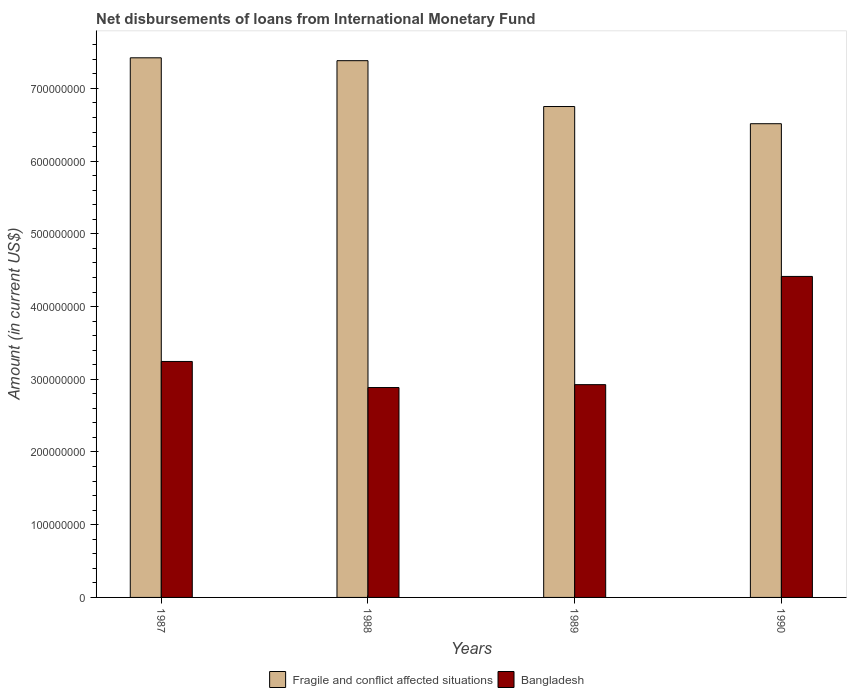Are the number of bars on each tick of the X-axis equal?
Offer a terse response. Yes. In how many cases, is the number of bars for a given year not equal to the number of legend labels?
Provide a succinct answer. 0. What is the amount of loans disbursed in Bangladesh in 1990?
Provide a short and direct response. 4.41e+08. Across all years, what is the maximum amount of loans disbursed in Fragile and conflict affected situations?
Your answer should be compact. 7.42e+08. Across all years, what is the minimum amount of loans disbursed in Bangladesh?
Provide a succinct answer. 2.89e+08. In which year was the amount of loans disbursed in Fragile and conflict affected situations maximum?
Offer a very short reply. 1987. In which year was the amount of loans disbursed in Bangladesh minimum?
Ensure brevity in your answer.  1988. What is the total amount of loans disbursed in Bangladesh in the graph?
Make the answer very short. 1.35e+09. What is the difference between the amount of loans disbursed in Bangladesh in 1987 and that in 1988?
Make the answer very short. 3.59e+07. What is the difference between the amount of loans disbursed in Bangladesh in 1987 and the amount of loans disbursed in Fragile and conflict affected situations in 1990?
Your answer should be very brief. -3.27e+08. What is the average amount of loans disbursed in Fragile and conflict affected situations per year?
Make the answer very short. 7.02e+08. In the year 1990, what is the difference between the amount of loans disbursed in Fragile and conflict affected situations and amount of loans disbursed in Bangladesh?
Offer a terse response. 2.10e+08. What is the ratio of the amount of loans disbursed in Bangladesh in 1987 to that in 1989?
Offer a very short reply. 1.11. Is the amount of loans disbursed in Fragile and conflict affected situations in 1987 less than that in 1988?
Your response must be concise. No. Is the difference between the amount of loans disbursed in Fragile and conflict affected situations in 1987 and 1989 greater than the difference between the amount of loans disbursed in Bangladesh in 1987 and 1989?
Offer a very short reply. Yes. What is the difference between the highest and the second highest amount of loans disbursed in Bangladesh?
Provide a succinct answer. 1.17e+08. What is the difference between the highest and the lowest amount of loans disbursed in Fragile and conflict affected situations?
Your response must be concise. 9.06e+07. Is the sum of the amount of loans disbursed in Fragile and conflict affected situations in 1988 and 1989 greater than the maximum amount of loans disbursed in Bangladesh across all years?
Your response must be concise. Yes. What does the 1st bar from the right in 1988 represents?
Ensure brevity in your answer.  Bangladesh. What is the difference between two consecutive major ticks on the Y-axis?
Make the answer very short. 1.00e+08. Does the graph contain any zero values?
Your response must be concise. No. Does the graph contain grids?
Make the answer very short. No. What is the title of the graph?
Provide a succinct answer. Net disbursements of loans from International Monetary Fund. Does "Heavily indebted poor countries" appear as one of the legend labels in the graph?
Your answer should be very brief. No. What is the Amount (in current US$) of Fragile and conflict affected situations in 1987?
Keep it short and to the point. 7.42e+08. What is the Amount (in current US$) of Bangladesh in 1987?
Offer a terse response. 3.24e+08. What is the Amount (in current US$) in Fragile and conflict affected situations in 1988?
Your answer should be compact. 7.38e+08. What is the Amount (in current US$) in Bangladesh in 1988?
Offer a very short reply. 2.89e+08. What is the Amount (in current US$) of Fragile and conflict affected situations in 1989?
Offer a very short reply. 6.75e+08. What is the Amount (in current US$) of Bangladesh in 1989?
Your response must be concise. 2.93e+08. What is the Amount (in current US$) in Fragile and conflict affected situations in 1990?
Your answer should be very brief. 6.51e+08. What is the Amount (in current US$) in Bangladesh in 1990?
Make the answer very short. 4.41e+08. Across all years, what is the maximum Amount (in current US$) of Fragile and conflict affected situations?
Offer a terse response. 7.42e+08. Across all years, what is the maximum Amount (in current US$) in Bangladesh?
Your answer should be very brief. 4.41e+08. Across all years, what is the minimum Amount (in current US$) of Fragile and conflict affected situations?
Ensure brevity in your answer.  6.51e+08. Across all years, what is the minimum Amount (in current US$) in Bangladesh?
Offer a very short reply. 2.89e+08. What is the total Amount (in current US$) of Fragile and conflict affected situations in the graph?
Your answer should be very brief. 2.81e+09. What is the total Amount (in current US$) in Bangladesh in the graph?
Provide a short and direct response. 1.35e+09. What is the difference between the Amount (in current US$) of Fragile and conflict affected situations in 1987 and that in 1988?
Your answer should be very brief. 3.95e+06. What is the difference between the Amount (in current US$) of Bangladesh in 1987 and that in 1988?
Offer a very short reply. 3.59e+07. What is the difference between the Amount (in current US$) in Fragile and conflict affected situations in 1987 and that in 1989?
Your answer should be compact. 6.70e+07. What is the difference between the Amount (in current US$) of Bangladesh in 1987 and that in 1989?
Your answer should be very brief. 3.19e+07. What is the difference between the Amount (in current US$) of Fragile and conflict affected situations in 1987 and that in 1990?
Offer a terse response. 9.06e+07. What is the difference between the Amount (in current US$) in Bangladesh in 1987 and that in 1990?
Offer a very short reply. -1.17e+08. What is the difference between the Amount (in current US$) in Fragile and conflict affected situations in 1988 and that in 1989?
Offer a terse response. 6.31e+07. What is the difference between the Amount (in current US$) in Bangladesh in 1988 and that in 1989?
Keep it short and to the point. -3.96e+06. What is the difference between the Amount (in current US$) in Fragile and conflict affected situations in 1988 and that in 1990?
Your answer should be compact. 8.67e+07. What is the difference between the Amount (in current US$) of Bangladesh in 1988 and that in 1990?
Ensure brevity in your answer.  -1.53e+08. What is the difference between the Amount (in current US$) in Fragile and conflict affected situations in 1989 and that in 1990?
Your response must be concise. 2.36e+07. What is the difference between the Amount (in current US$) in Bangladesh in 1989 and that in 1990?
Your answer should be compact. -1.49e+08. What is the difference between the Amount (in current US$) in Fragile and conflict affected situations in 1987 and the Amount (in current US$) in Bangladesh in 1988?
Give a very brief answer. 4.53e+08. What is the difference between the Amount (in current US$) of Fragile and conflict affected situations in 1987 and the Amount (in current US$) of Bangladesh in 1989?
Offer a very short reply. 4.49e+08. What is the difference between the Amount (in current US$) in Fragile and conflict affected situations in 1987 and the Amount (in current US$) in Bangladesh in 1990?
Provide a short and direct response. 3.01e+08. What is the difference between the Amount (in current US$) of Fragile and conflict affected situations in 1988 and the Amount (in current US$) of Bangladesh in 1989?
Your answer should be compact. 4.46e+08. What is the difference between the Amount (in current US$) of Fragile and conflict affected situations in 1988 and the Amount (in current US$) of Bangladesh in 1990?
Your answer should be compact. 2.97e+08. What is the difference between the Amount (in current US$) in Fragile and conflict affected situations in 1989 and the Amount (in current US$) in Bangladesh in 1990?
Ensure brevity in your answer.  2.34e+08. What is the average Amount (in current US$) in Fragile and conflict affected situations per year?
Your answer should be very brief. 7.02e+08. What is the average Amount (in current US$) in Bangladesh per year?
Keep it short and to the point. 3.37e+08. In the year 1987, what is the difference between the Amount (in current US$) in Fragile and conflict affected situations and Amount (in current US$) in Bangladesh?
Offer a very short reply. 4.18e+08. In the year 1988, what is the difference between the Amount (in current US$) in Fragile and conflict affected situations and Amount (in current US$) in Bangladesh?
Offer a terse response. 4.49e+08. In the year 1989, what is the difference between the Amount (in current US$) of Fragile and conflict affected situations and Amount (in current US$) of Bangladesh?
Offer a terse response. 3.82e+08. In the year 1990, what is the difference between the Amount (in current US$) in Fragile and conflict affected situations and Amount (in current US$) in Bangladesh?
Provide a succinct answer. 2.10e+08. What is the ratio of the Amount (in current US$) of Fragile and conflict affected situations in 1987 to that in 1988?
Your answer should be very brief. 1.01. What is the ratio of the Amount (in current US$) in Bangladesh in 1987 to that in 1988?
Give a very brief answer. 1.12. What is the ratio of the Amount (in current US$) of Fragile and conflict affected situations in 1987 to that in 1989?
Offer a terse response. 1.1. What is the ratio of the Amount (in current US$) of Bangladesh in 1987 to that in 1989?
Your answer should be compact. 1.11. What is the ratio of the Amount (in current US$) of Fragile and conflict affected situations in 1987 to that in 1990?
Your answer should be compact. 1.14. What is the ratio of the Amount (in current US$) of Bangladesh in 1987 to that in 1990?
Ensure brevity in your answer.  0.74. What is the ratio of the Amount (in current US$) of Fragile and conflict affected situations in 1988 to that in 1989?
Your response must be concise. 1.09. What is the ratio of the Amount (in current US$) of Bangladesh in 1988 to that in 1989?
Provide a short and direct response. 0.99. What is the ratio of the Amount (in current US$) of Fragile and conflict affected situations in 1988 to that in 1990?
Make the answer very short. 1.13. What is the ratio of the Amount (in current US$) of Bangladesh in 1988 to that in 1990?
Provide a short and direct response. 0.65. What is the ratio of the Amount (in current US$) in Fragile and conflict affected situations in 1989 to that in 1990?
Provide a succinct answer. 1.04. What is the ratio of the Amount (in current US$) of Bangladesh in 1989 to that in 1990?
Ensure brevity in your answer.  0.66. What is the difference between the highest and the second highest Amount (in current US$) of Fragile and conflict affected situations?
Keep it short and to the point. 3.95e+06. What is the difference between the highest and the second highest Amount (in current US$) in Bangladesh?
Provide a short and direct response. 1.17e+08. What is the difference between the highest and the lowest Amount (in current US$) of Fragile and conflict affected situations?
Offer a terse response. 9.06e+07. What is the difference between the highest and the lowest Amount (in current US$) in Bangladesh?
Ensure brevity in your answer.  1.53e+08. 